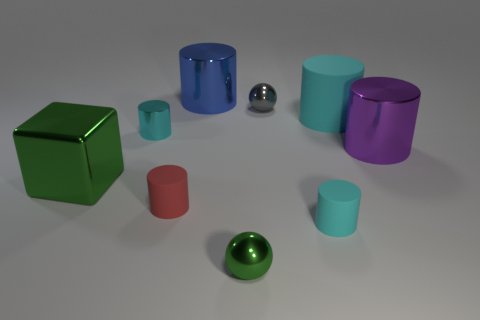Are there more large things than gray metal cylinders?
Make the answer very short. Yes. There is a cyan cylinder to the left of the gray shiny thing; is its size the same as the tiny green ball?
Give a very brief answer. Yes. What number of small spheres are the same color as the big block?
Keep it short and to the point. 1. Is the small red object the same shape as the small green object?
Provide a short and direct response. No. What is the size of the blue object that is the same shape as the purple thing?
Your answer should be very brief. Large. Is the number of tiny red rubber cylinders that are in front of the purple cylinder greater than the number of tiny cyan cylinders that are in front of the tiny green ball?
Offer a terse response. Yes. Is the blue cylinder made of the same material as the large cylinder that is in front of the tiny cyan metallic thing?
Your response must be concise. Yes. Is there any other thing that has the same shape as the big green thing?
Ensure brevity in your answer.  No. There is a matte object that is in front of the large cyan cylinder and on the right side of the small gray object; what is its color?
Your response must be concise. Cyan. What is the shape of the green metallic object in front of the big green cube?
Your response must be concise. Sphere. 